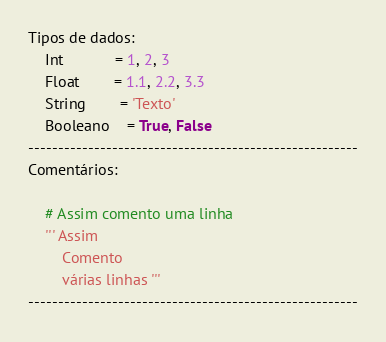<code> <loc_0><loc_0><loc_500><loc_500><_Python_>Tipos de dados:
	Int			= 1, 2, 3
	Float		= 1.1, 2.2, 3.3
	String		= 'Texto'
	Booleano	= True, False
-------------------------------------------------------
Comentários:

	# Assim comento uma linha
	''' Assim
		Comento
		várias linhas '''
-------------------------------------------------------</code> 